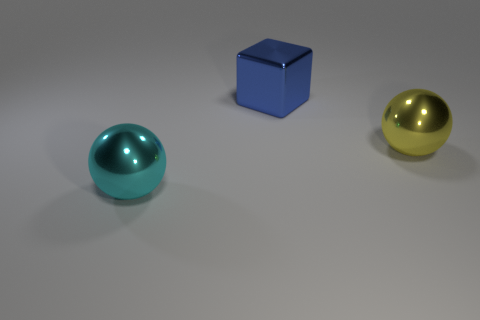Subtract all yellow spheres. How many spheres are left? 1 Subtract all balls. How many objects are left? 1 Subtract 1 cubes. How many cubes are left? 0 Subtract all tiny brown rubber blocks. Subtract all cyan shiny objects. How many objects are left? 2 Add 2 shiny balls. How many shiny balls are left? 4 Add 1 large green shiny things. How many large green shiny things exist? 1 Add 1 large red shiny spheres. How many objects exist? 4 Subtract 1 blue blocks. How many objects are left? 2 Subtract all purple cubes. Subtract all gray cylinders. How many cubes are left? 1 Subtract all green blocks. How many yellow balls are left? 1 